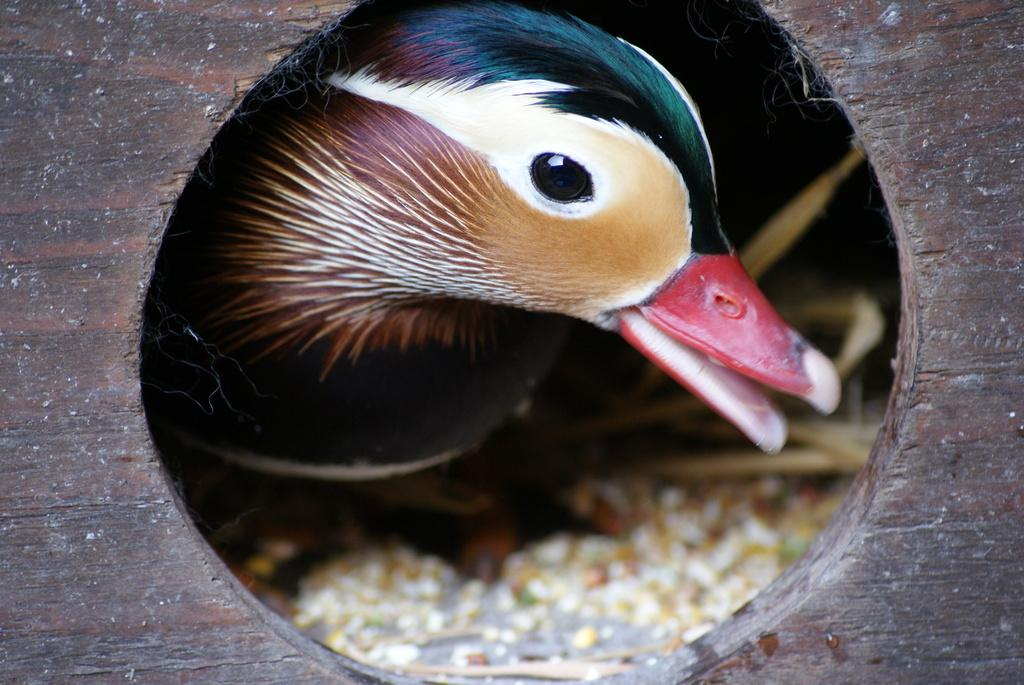What type of animal can be seen in the image? There is a bird in the image. Where is the bird located? The bird is in a birdhouse. What type of sack is hanging near the birdhouse in the image? There is no sack present in the image; it only features a bird in a birdhouse. 